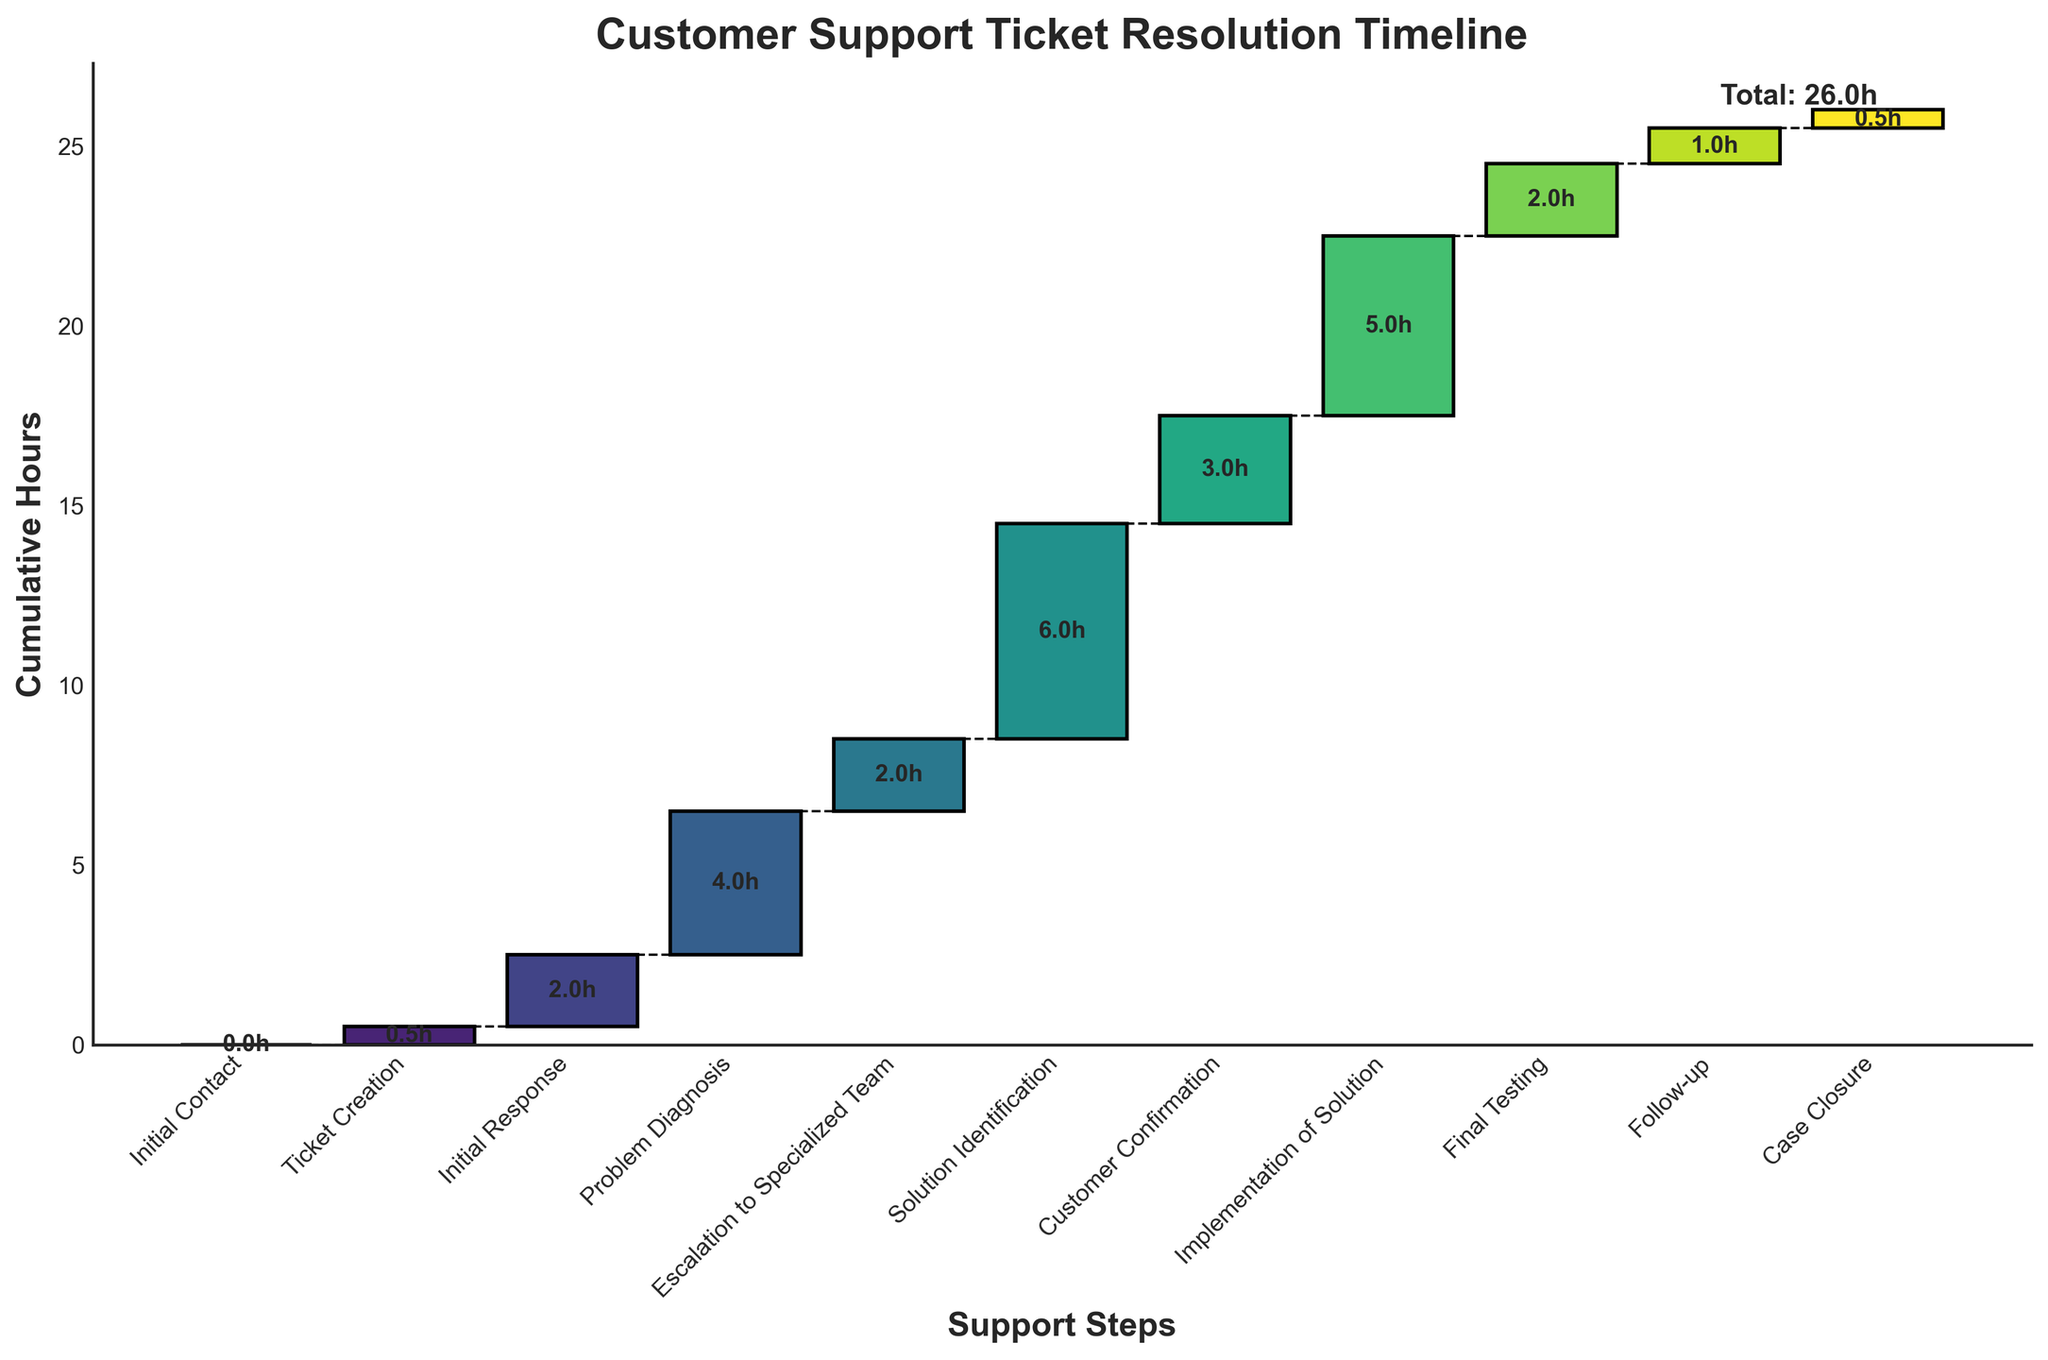How much time is spent on the initial response? The initial response time is displayed as one of the steps in the chart, marked "Initial Response". According to the bar representing it, 2 hours are spent on this step.
Answer: 2 hours What is the total time taken for the resolution from the initial contact to case closure? The chart shows cumulative hours for each step. To find the total time, you can look at the final cumulative value on the rightmost part of the chart, which represents the total time from start to finish.
Answer: 26 hours What steps take the longest time individually? By comparing the heights of the bars in the waterfall chart, it's evident that the "Solution Identification" step has the longest bar, indicating it takes the most time.
Answer: Solution Identification What is the cumulative time by the problem diagnosis step? To find this, add up the hours from "Initial Contact" through "Problem Diagnosis": 0 (Initial Contact) + 0.5 (Ticket Creation) + 2 (Initial Response) + 4 (Problem Diagnosis). The cumulative time is shown at the top end of the "Problem Diagnosis" bar as well.
Answer: 6.5 hours Which steps take less than 1 hour to complete? By observing the bars in the chart, we can see that "Initial Contact", "Ticket Creation", "Follow-up", and "Case Closure" each have bars less than 1 hour tall.
Answer: Initial Contact, Ticket Creation, Follow-up, Case Closure How much time is saved by not requiring escalation to a specialized team? The time taken for "Escalation to Specialized Team" is given by its individual bar, which is 2 hours.
Answer: 2 hours What steps contribute to more than 3 hours individually? Observing the heights of the bars, "Solution Identification," "Problem Diagnosis," and "Implementation of Solution" each have bars taller than 3 hours.
Answer: Solution Identification, Problem Diagnosis, Implementation of Solution How does the time taken for initial response compare to customer confirmation? By comparing the heights of the bars, the time taken for "Initial Response" is 2 hours, and for "Customer Confirmation" it is 3 hours, meaning customer confirmation takes 1 hour longer than the initial response.
Answer: Customer Confirmation takes 1 hour longer than Initial Response What is the time difference between implementation of solution and final testing? From the chart, the "Implementation of Solution" step takes 5 hours, whereas "Final Testing" takes 2 hours. The difference between these two steps is 5 - 2 = 3 hours.
Answer: 3 hours 